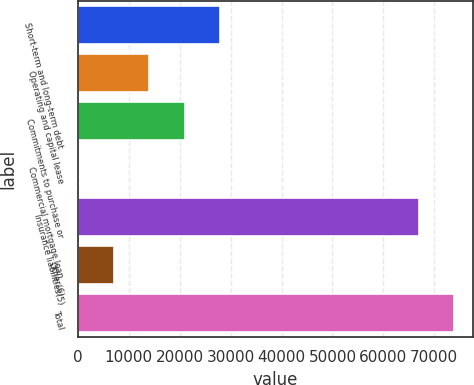Convert chart to OTSL. <chart><loc_0><loc_0><loc_500><loc_500><bar_chart><fcel>Short-term and long-term debt<fcel>Operating and capital lease<fcel>Commitments to purchase or<fcel>Commercial mortgage loan<fcel>Insurance liabilities(5)<fcel>Other(6)<fcel>Total<nl><fcel>27991<fcel>13996.4<fcel>20993.7<fcel>1.76<fcel>66945<fcel>6999.08<fcel>73942.3<nl></chart> 